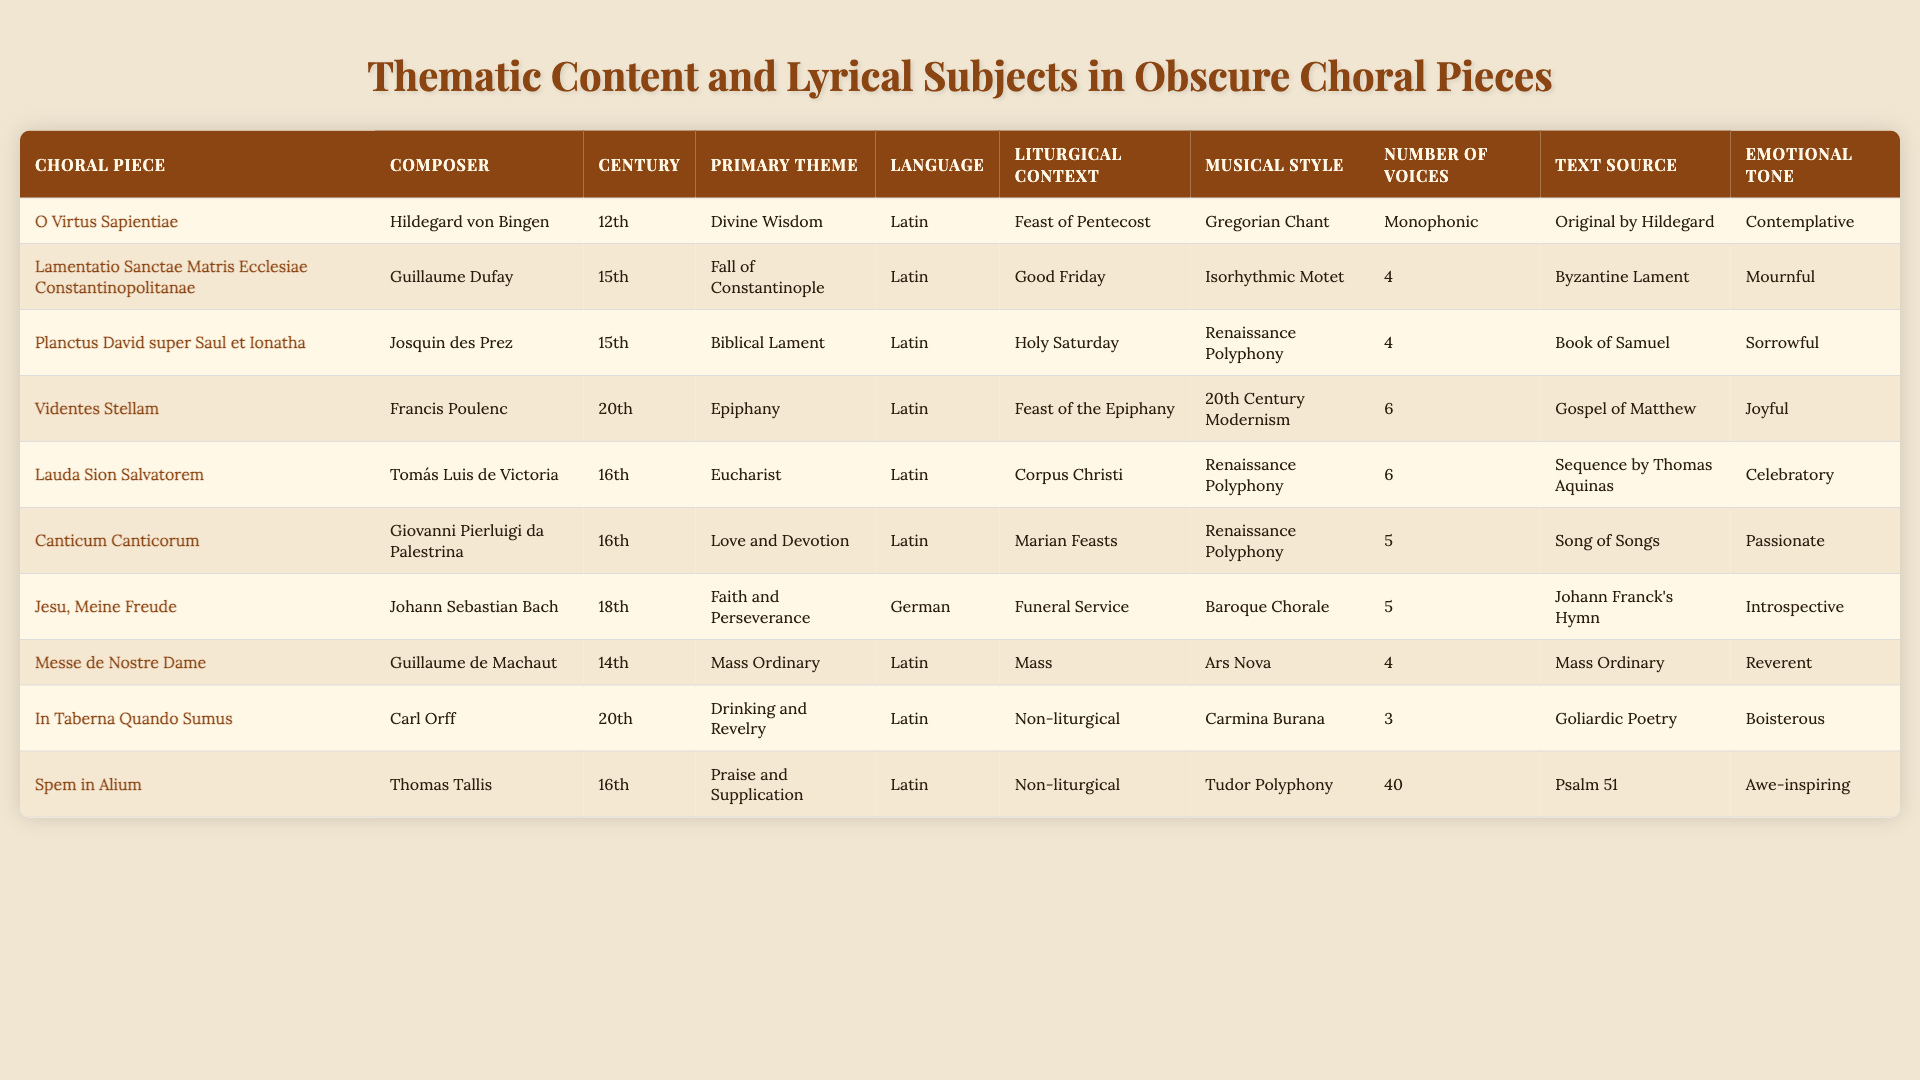What is the primary theme of "Jesu, Meine Freude"? The table indicates that the primary theme of "Jesu, Meine Freude" by Johann Sebastian Bach is "Faith and Perseverance."
Answer: Faith and Perseverance Who composed "Lamentatio Sanctae Matris Ecclesiae Constantinopolitanae"? According to the table, "Lamentatio Sanctae Matris Ecclesiae Constantinopolitanae" was composed by Guillaume Dufay.
Answer: Guillaume Dufay How many choral pieces are from the 16th century? The table shows three pieces from the 16th century: "Lauda Sion Salvatorem," "Canticum Canticorum," and "In Taberna Quando Sumus." This leads to the answer being 3.
Answer: 3 Which piece has the most voices, and how many are there? The entry for "Spem in Alium" indicates it has 40 voices, making it the piece with the most voices in the table.
Answer: "Spem in Alium" and 40 voices Is "Planctus David super Saul et Ionatha" in Latin? The table shows that "Planctus David super Saul et Ionatha" is in Latin, as indicated by its language entry.
Answer: Yes What is the average number of voices for pieces composed in the 15th century? The two pieces from the 15th century, "Lamentatio Sanctae Matris Ecclesiae Constantinopolitanae" and "Planctus David super Saul et Ionatha," have 4 voices each. The average is (4 + 4) / 2 = 4.
Answer: 4 Identify the pieces with a liturgical context of "Non-liturgical." The table reveals that "In Taberna Quando Sumus" and "Spem in Alium" have a liturgical context of "Non-liturgical."
Answer: "In Taberna Quando Sumus" and "Spem in Alium" How does the emotional tone of "Videntes Stellam" compare to "O Virtus Sapientiae"? "Videntes Stellam" has a joyful tone while "O Virtus Sapientiae" is contemplative; thus, their tones differ significantly in mood.
Answer: They differ in tones; joyful vs. contemplative From the table, which piece has the text source of "Song of Songs"? The piece with the text source of "Song of Songs" is "Canticum Canticorum" by Giovanni Pierluigi da Palestrina.
Answer: "Canticum Canticorum" What is the relationship between the primary theme and emotional tone of "Lauda Sion Salvatorem"? The primary theme of "Lauda Sion Salvatorem" is the Eucharist, and its emotional tone is celebratory, suggesting a connection of joy and reverence for the sacrament.
Answer: They are connected; theme is Eucharist, tone is celebratory 